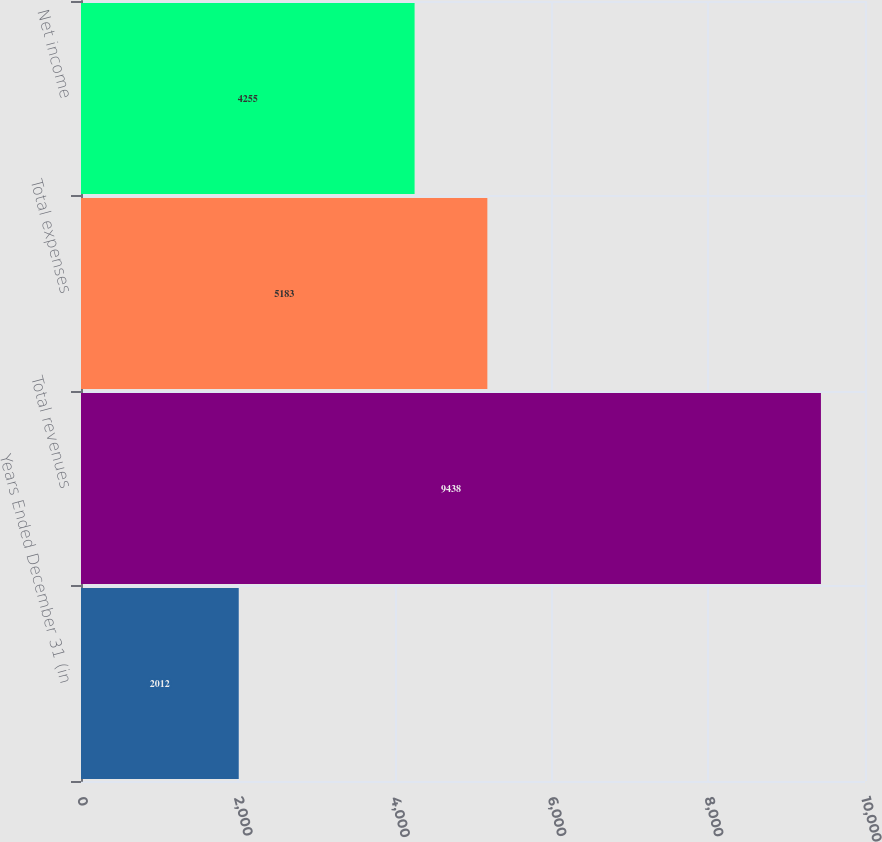<chart> <loc_0><loc_0><loc_500><loc_500><bar_chart><fcel>Years Ended December 31 (in<fcel>Total revenues<fcel>Total expenses<fcel>Net income<nl><fcel>2012<fcel>9438<fcel>5183<fcel>4255<nl></chart> 